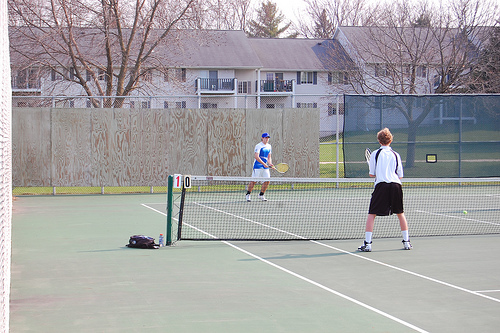What sport are the individuals playing? The individuals in the image are playing tennis, which is indicated by the tennis rackets in their hands and the net in between. Does it look like a professional match? No, it does not appear to be a professional match. The setting looks more casual and recreational, possibly at a park or school, as there are no spectator stands or official markings for a professional event. 